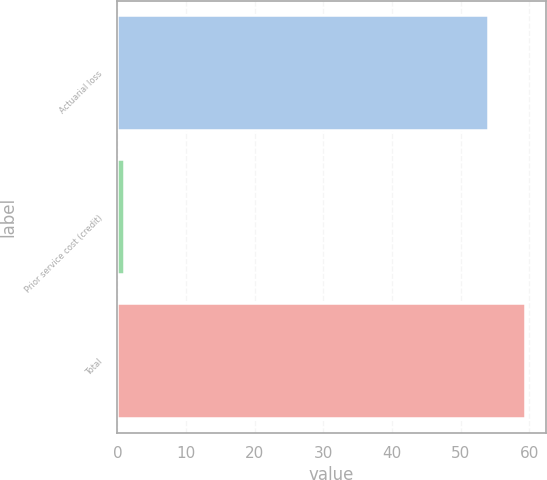Convert chart. <chart><loc_0><loc_0><loc_500><loc_500><bar_chart><fcel>Actuarial loss<fcel>Prior service cost (credit)<fcel>Total<nl><fcel>54<fcel>1<fcel>59.4<nl></chart> 